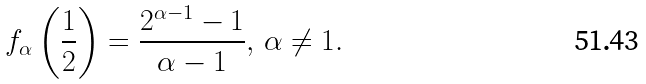Convert formula to latex. <formula><loc_0><loc_0><loc_500><loc_500>f _ { \alpha } \left ( \frac { 1 } { 2 } \right ) = \frac { 2 ^ { \alpha - 1 } - 1 } { \alpha - 1 } , \, \alpha \neq 1 .</formula> 